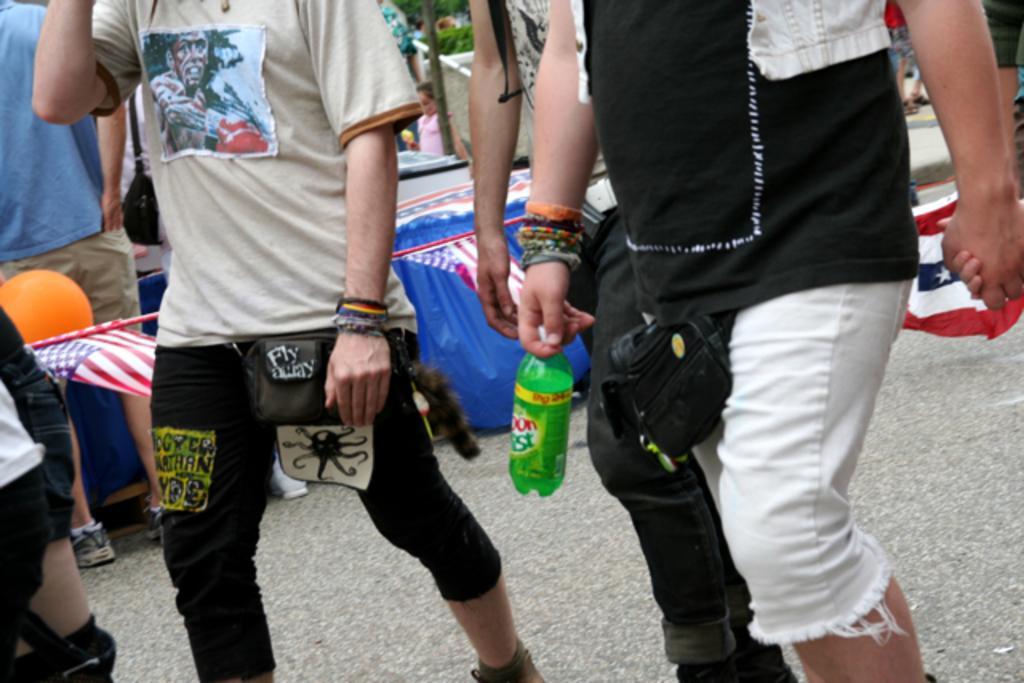How would you summarize this image in a sentence or two? As we can see in the image, there are few people walking on road. The person who is walking on the right side is holding bottle in his hand. 